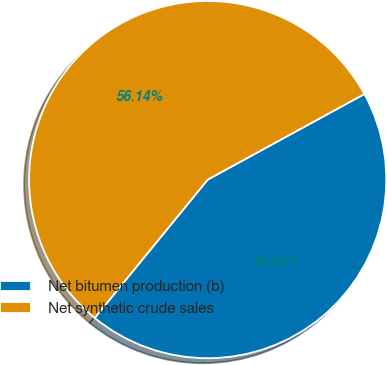Convert chart. <chart><loc_0><loc_0><loc_500><loc_500><pie_chart><fcel>Net bitumen production (b)<fcel>Net synthetic crude sales<nl><fcel>43.86%<fcel>56.14%<nl></chart> 